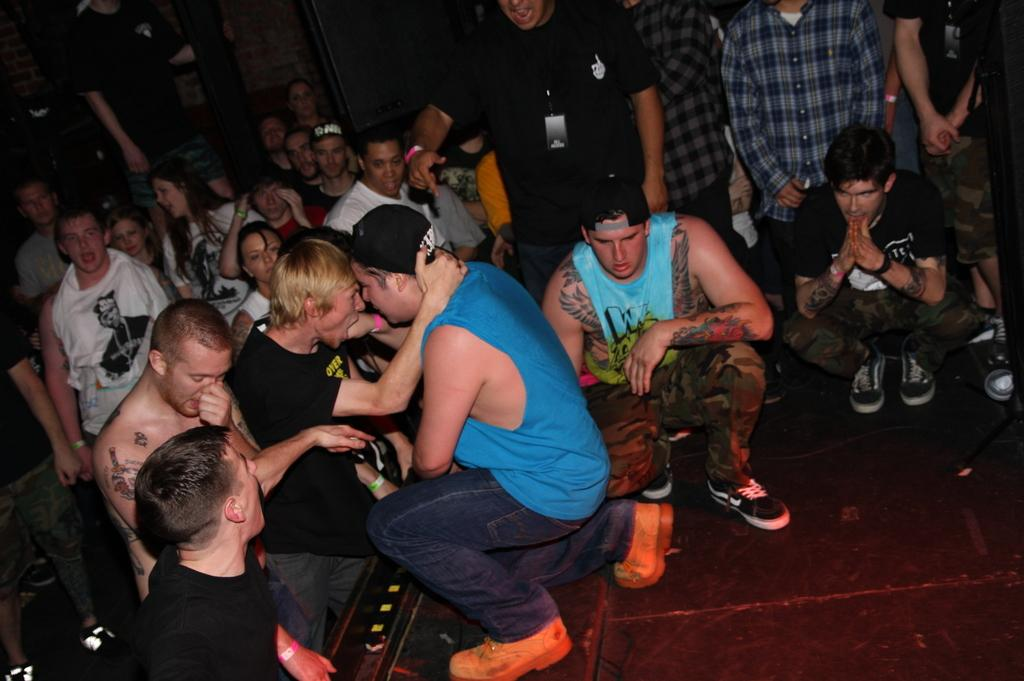How many people are in the image? There is a group of persons in the image. What are some of the positions of the persons in the image? Some of the persons are standing, and some are squatting. What type of cap is the zoo animal wearing in the image? There is no zoo animal or cap present in the image. 